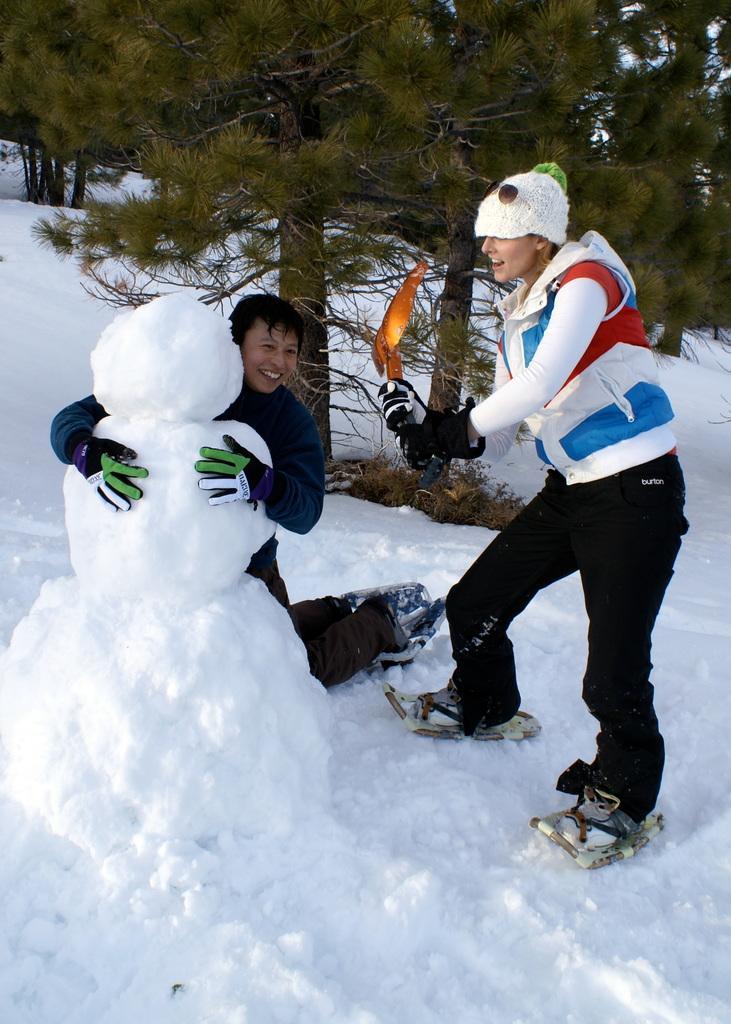Could you give a brief overview of what you see in this image? Here in this picture we can see a couple of people standing on the ground, which is fully covered with snow over there and the person on the left side is holding a doll, which is prepared with snow present in front of him and we can see both of them are wearing jackets and gloves and skating shoes on them and behind them we can see trees present all over there. 